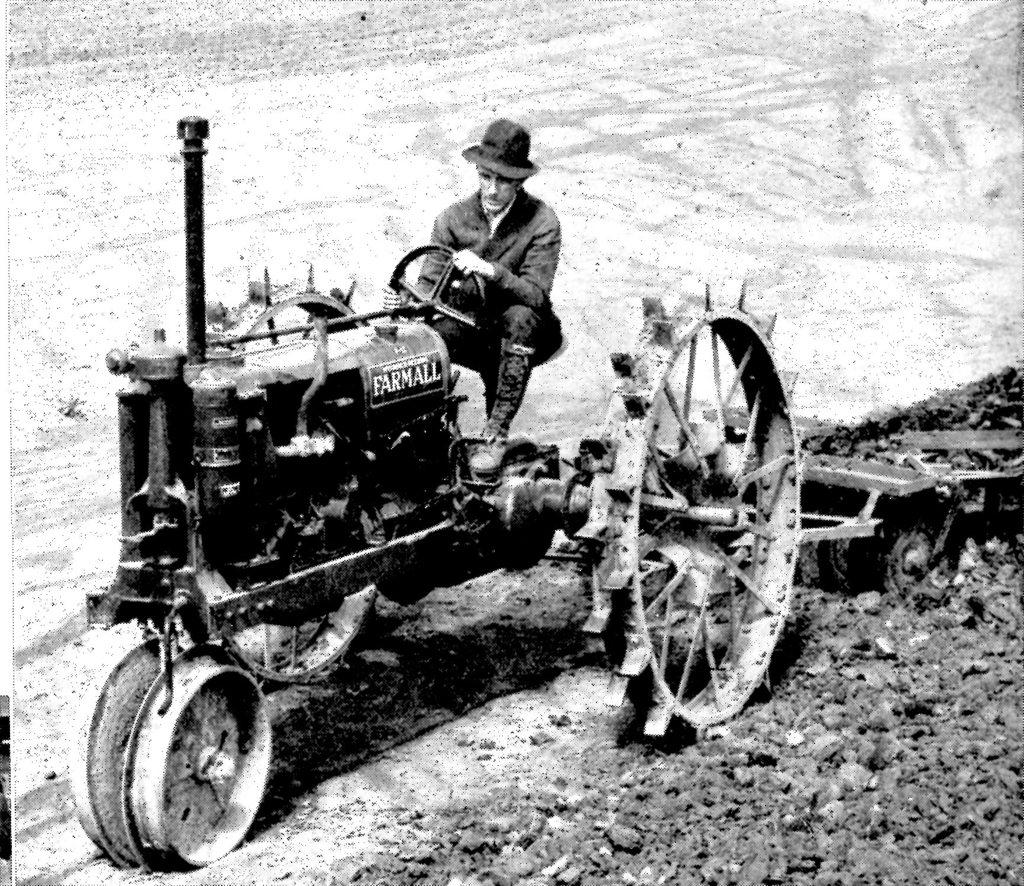What is the color scheme of the image? The image is black and white. What is the man in the image doing? The man is sitting on a tractor. What can be seen on the ground at the bottom of the image? There are stones on the ground at the bottom of the image. How many coils are visible on the tractor in the image? There is no mention of coils in the image, so it is impossible to determine their presence or quantity. What country is the man in the image from? The image does not provide any information about the man's nationality or the location of the tractor, so it cannot be determined from the image. 